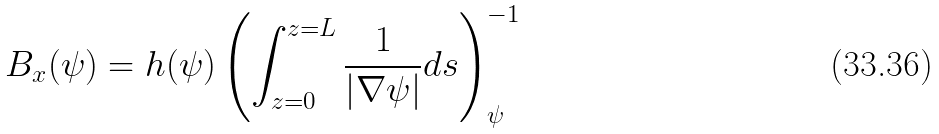<formula> <loc_0><loc_0><loc_500><loc_500>B _ { x } ( \psi ) = h ( \psi ) \left ( \int _ { z = 0 } ^ { z = L } \frac { 1 } { \left | \nabla \psi \right | } d s \right ) _ { \psi } ^ { - 1 }</formula> 